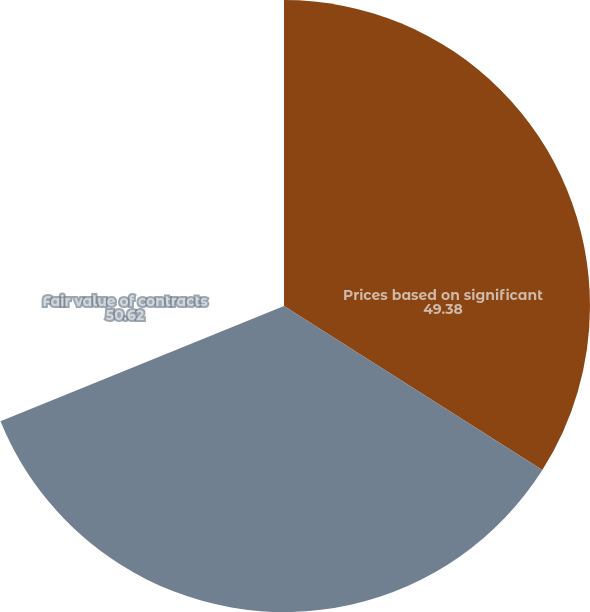Convert chart to OTSL. <chart><loc_0><loc_0><loc_500><loc_500><pie_chart><fcel>Prices based on significant<fcel>Fair value of contracts<nl><fcel>49.38%<fcel>50.62%<nl></chart> 